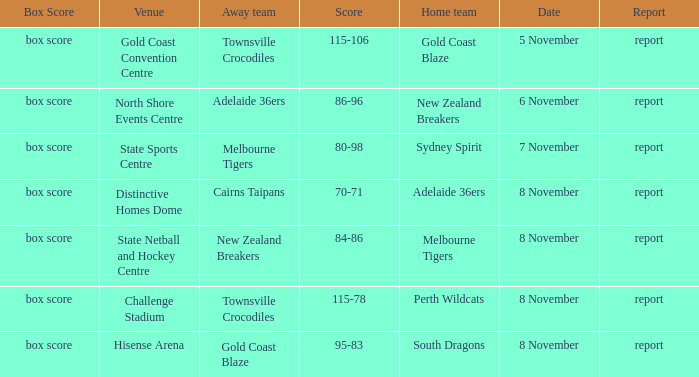What was the date that featured a game against Gold Coast Blaze? 8 November. 